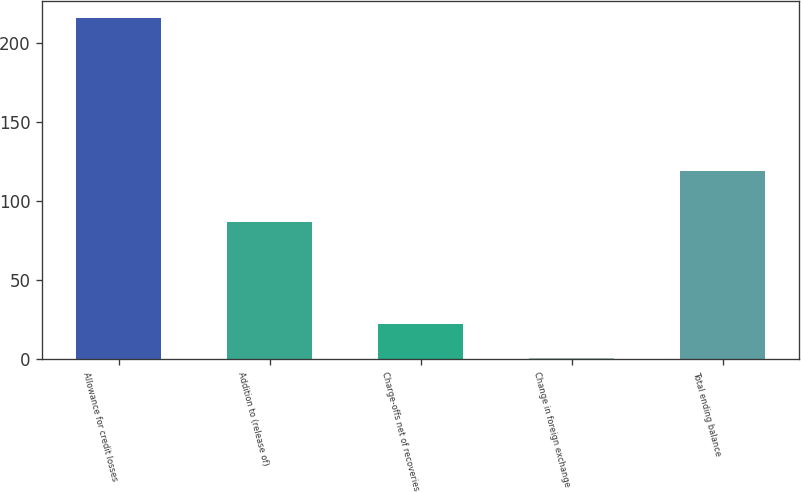Convert chart. <chart><loc_0><loc_0><loc_500><loc_500><bar_chart><fcel>Allowance for credit losses<fcel>Addition to (release of)<fcel>Charge-offs net of recoveries<fcel>Change in foreign exchange<fcel>Total ending balance<nl><fcel>216<fcel>87<fcel>22.5<fcel>1<fcel>119<nl></chart> 